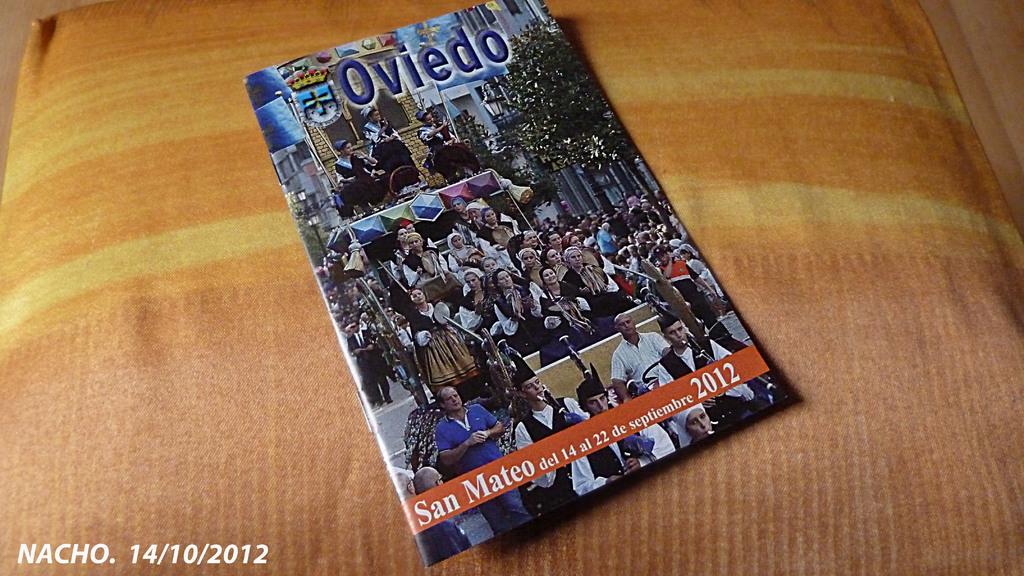What is the title of the book?
Give a very brief answer. Oviedo. 